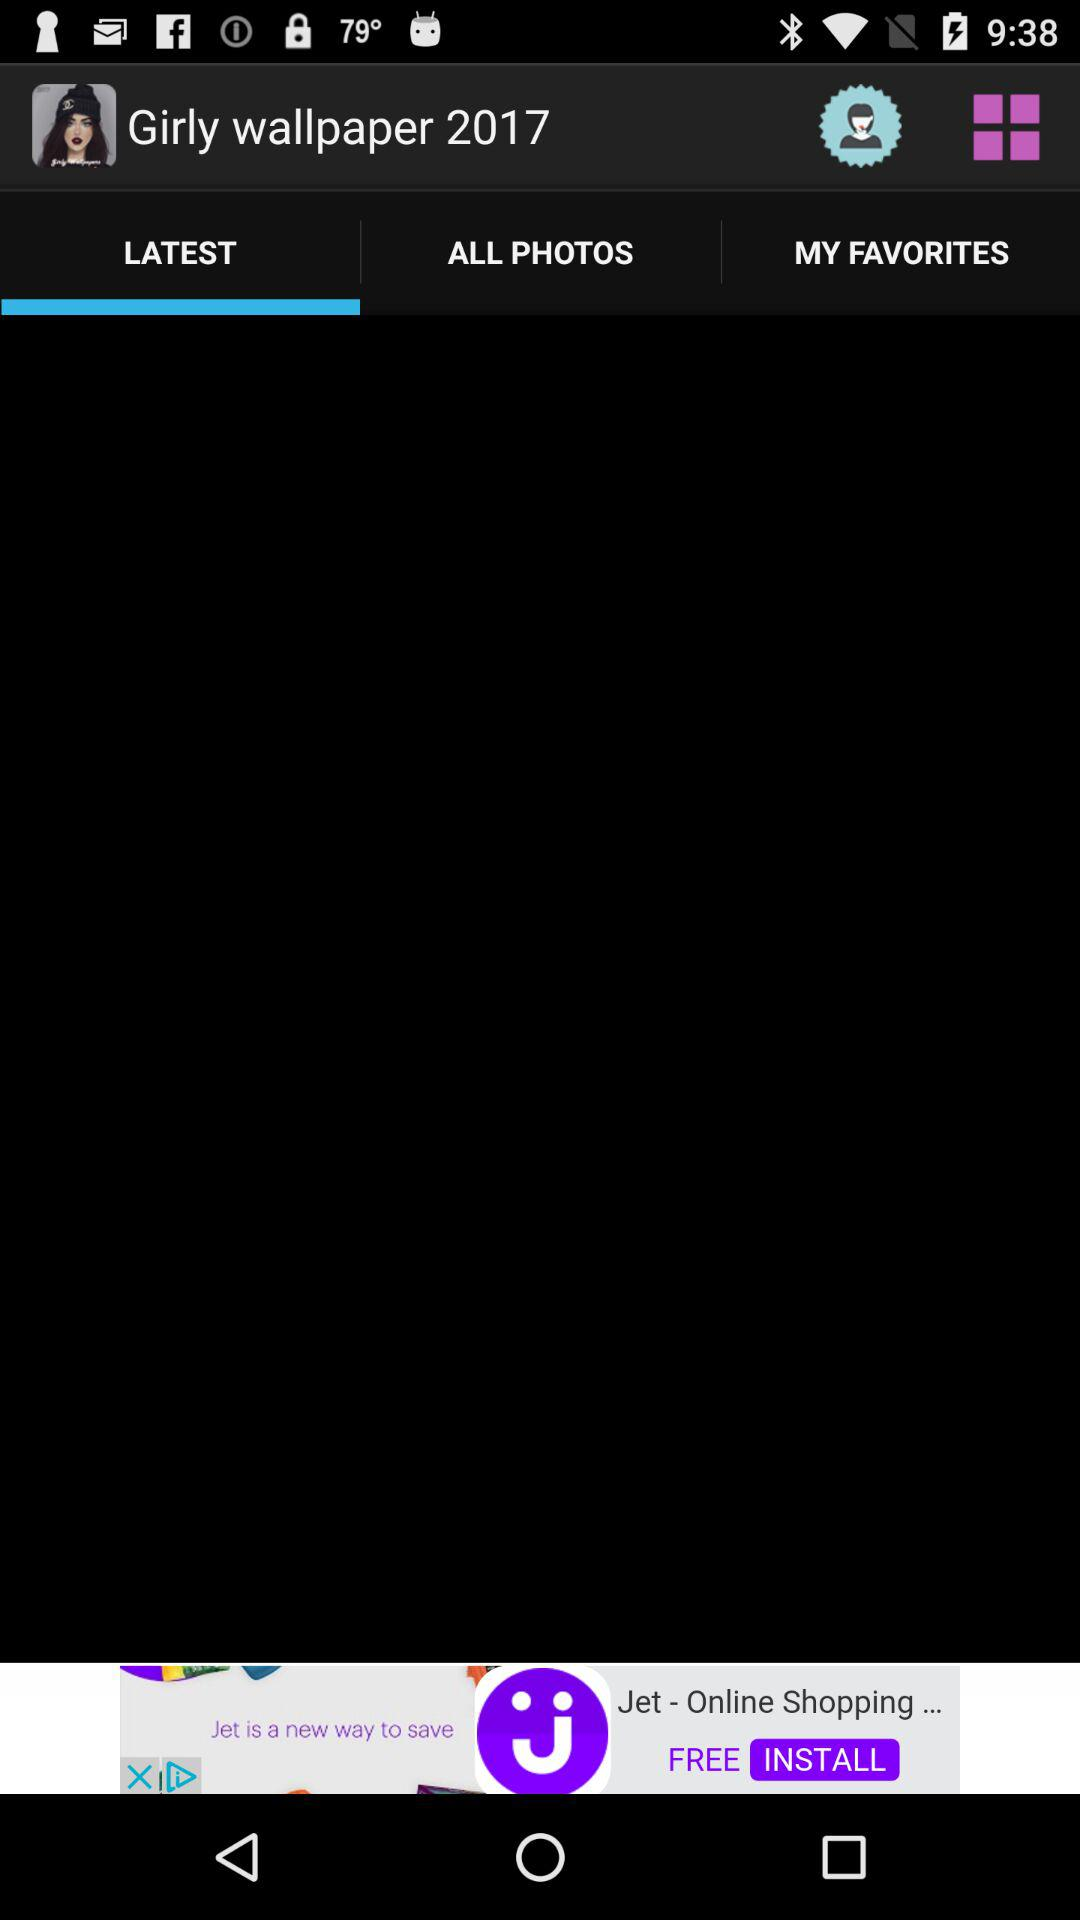What are the names of the listed items in "MY FAVORITES?"
When the provided information is insufficient, respond with <no answer>. <no answer> 